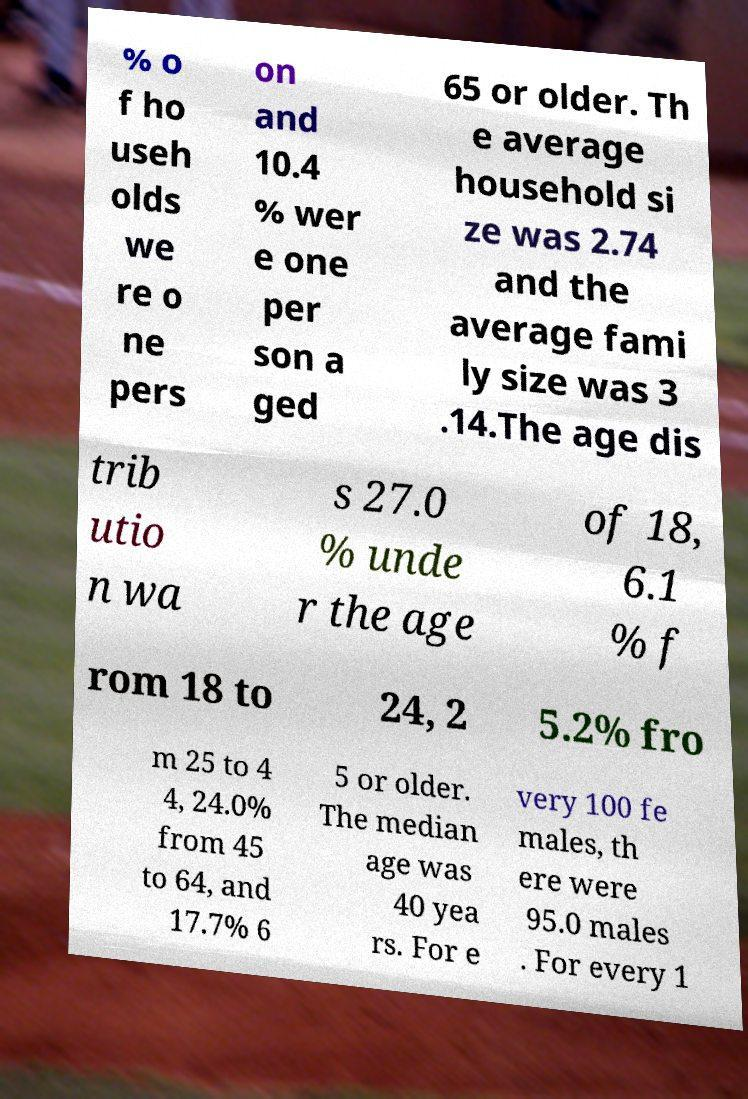Please identify and transcribe the text found in this image. % o f ho useh olds we re o ne pers on and 10.4 % wer e one per son a ged 65 or older. Th e average household si ze was 2.74 and the average fami ly size was 3 .14.The age dis trib utio n wa s 27.0 % unde r the age of 18, 6.1 % f rom 18 to 24, 2 5.2% fro m 25 to 4 4, 24.0% from 45 to 64, and 17.7% 6 5 or older. The median age was 40 yea rs. For e very 100 fe males, th ere were 95.0 males . For every 1 